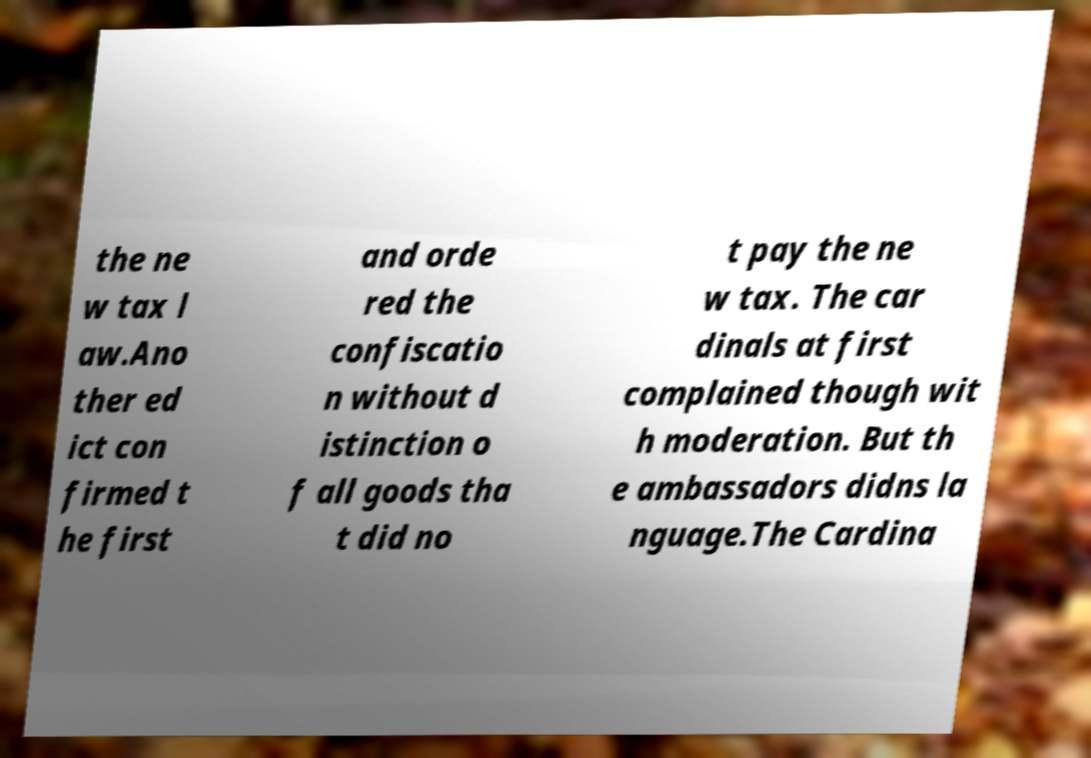What messages or text are displayed in this image? I need them in a readable, typed format. the ne w tax l aw.Ano ther ed ict con firmed t he first and orde red the confiscatio n without d istinction o f all goods tha t did no t pay the ne w tax. The car dinals at first complained though wit h moderation. But th e ambassadors didns la nguage.The Cardina 